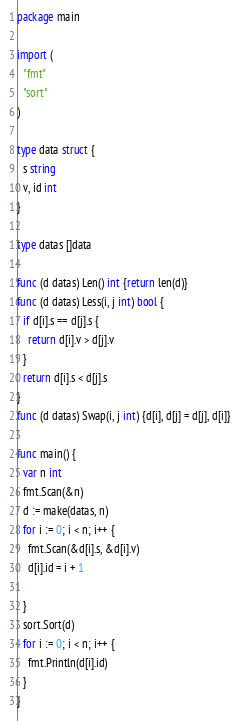Convert code to text. <code><loc_0><loc_0><loc_500><loc_500><_Go_>package main

import (
  "fmt"
  "sort"
)

type data struct {
  s string 
  v, id int
}

type datas []data

func (d datas) Len() int {return len(d)}
func (d datas) Less(i, j int) bool {
  if d[i].s == d[j].s {
    return d[i].v > d[j].v
  }
  return d[i].s < d[j].s
}
func (d datas) Swap(i, j int) {d[i], d[j] = d[j], d[i]}

func main() {
  var n int 
  fmt.Scan(&n)
  d := make(datas, n)
  for i := 0; i < n; i++ {
    fmt.Scan(&d[i].s, &d[i].v)
    d[i].id = i + 1

  }
  sort.Sort(d)
  for i := 0; i < n; i++ {
    fmt.Println(d[i].id)
  }
}</code> 